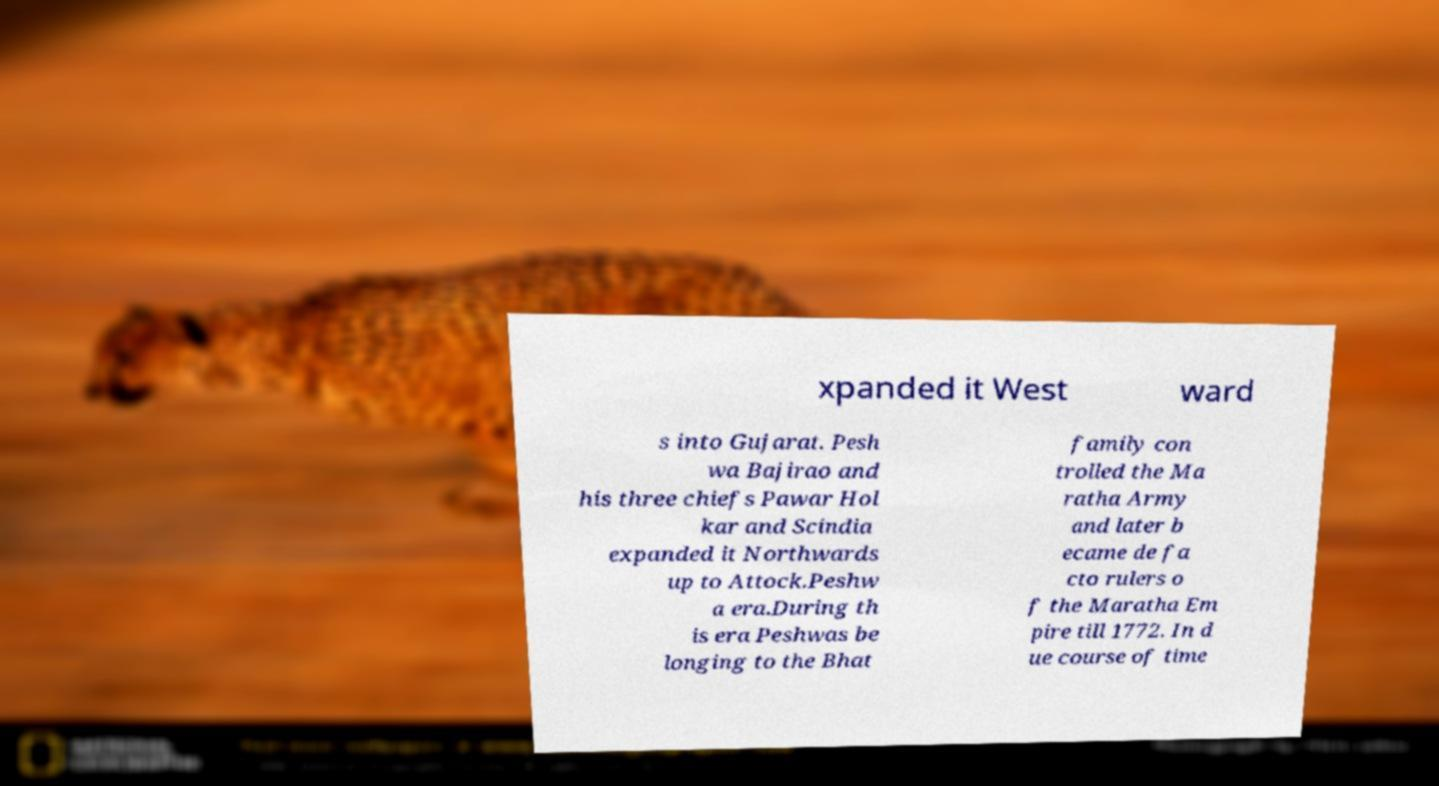Please identify and transcribe the text found in this image. xpanded it West ward s into Gujarat. Pesh wa Bajirao and his three chiefs Pawar Hol kar and Scindia expanded it Northwards up to Attock.Peshw a era.During th is era Peshwas be longing to the Bhat family con trolled the Ma ratha Army and later b ecame de fa cto rulers o f the Maratha Em pire till 1772. In d ue course of time 